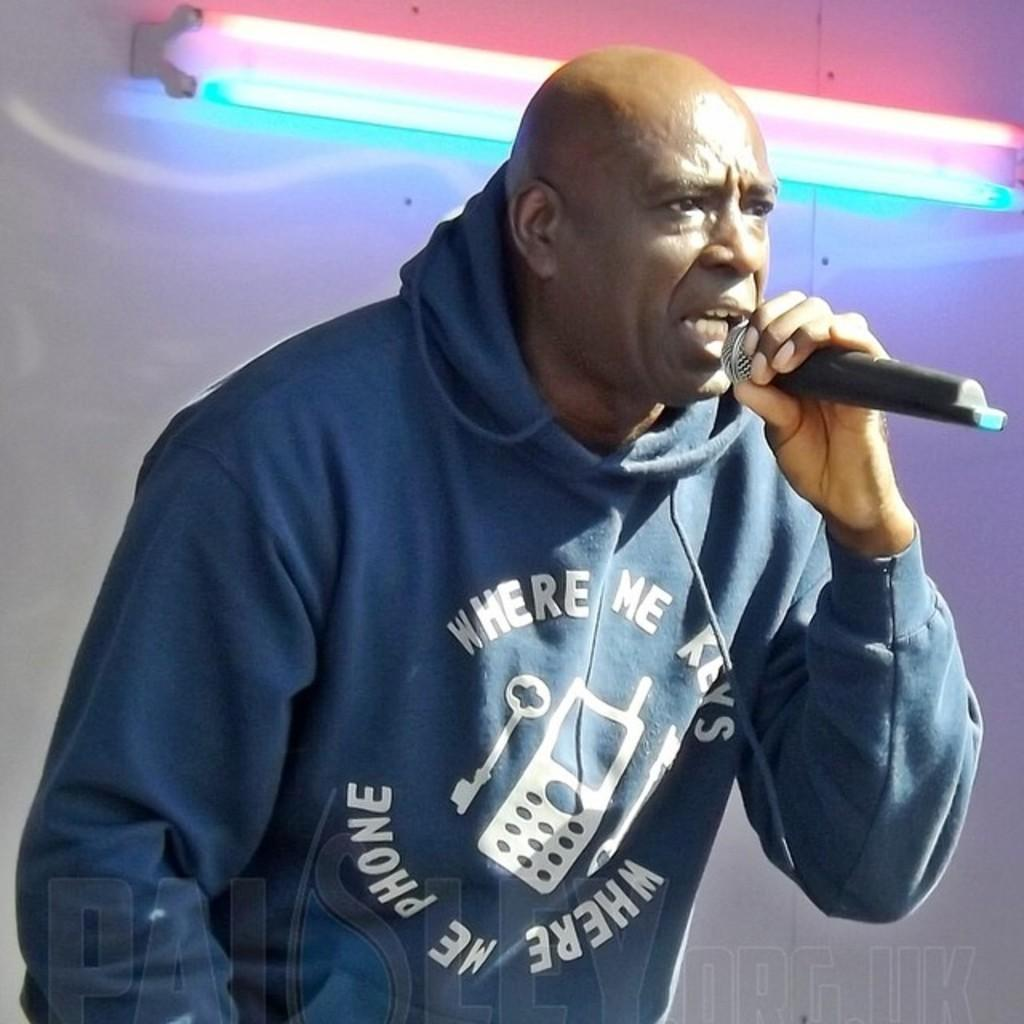What is the main subject of the image? There is a man standing in the middle of the image. What is the man holding in the image? The man is holding a microphone. What is the man doing in the image? The man is singing. What can be seen behind the man in the image? There is a wall behind the man. What is on the wall in the image? There is a light on the wall. What type of whip is the man using to sing in the image? There is no whip present in the image; the man is using a microphone to sing. 